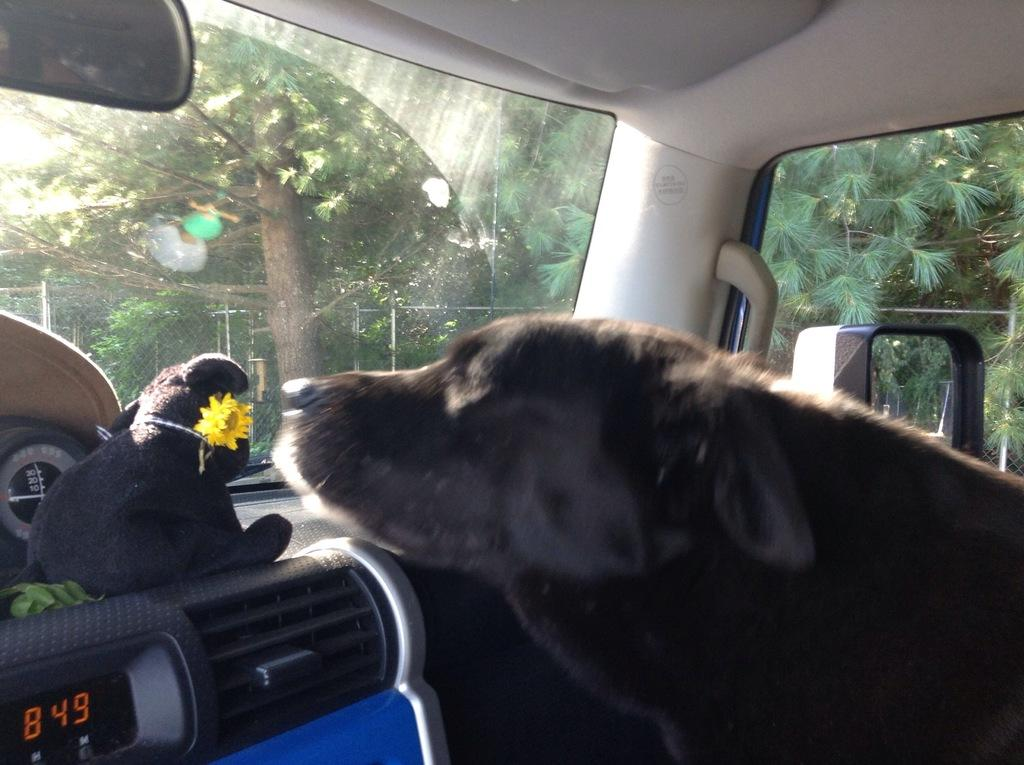Where was the photo taken? The photo was taken inside a vehicle. What can be seen inside the vehicle? There is a dog, a glass window, a vent, and a soft toy inside the vehicle. What is visible outside the vehicle? Trees are visible outside the vehicle. How long does it take for the dog to rest in the image? The image does not show the dog resting, nor does it provide information about the duration of any rest. 